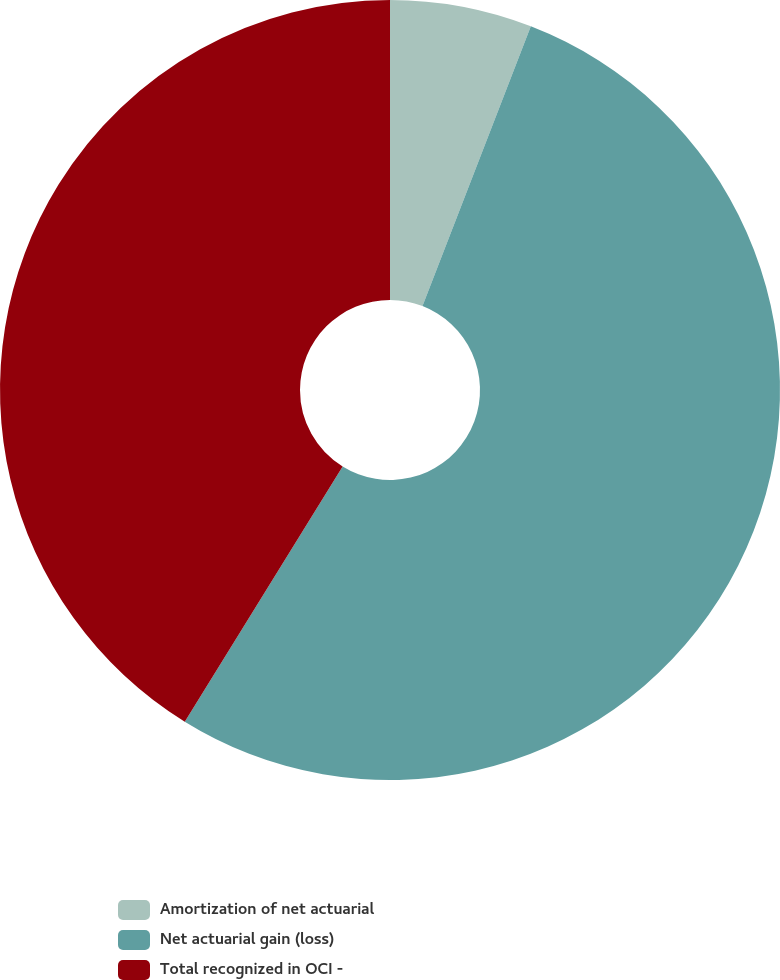Convert chart to OTSL. <chart><loc_0><loc_0><loc_500><loc_500><pie_chart><fcel>Amortization of net actuarial<fcel>Net actuarial gain (loss)<fcel>Total recognized in OCI -<nl><fcel>5.88%<fcel>52.94%<fcel>41.18%<nl></chart> 